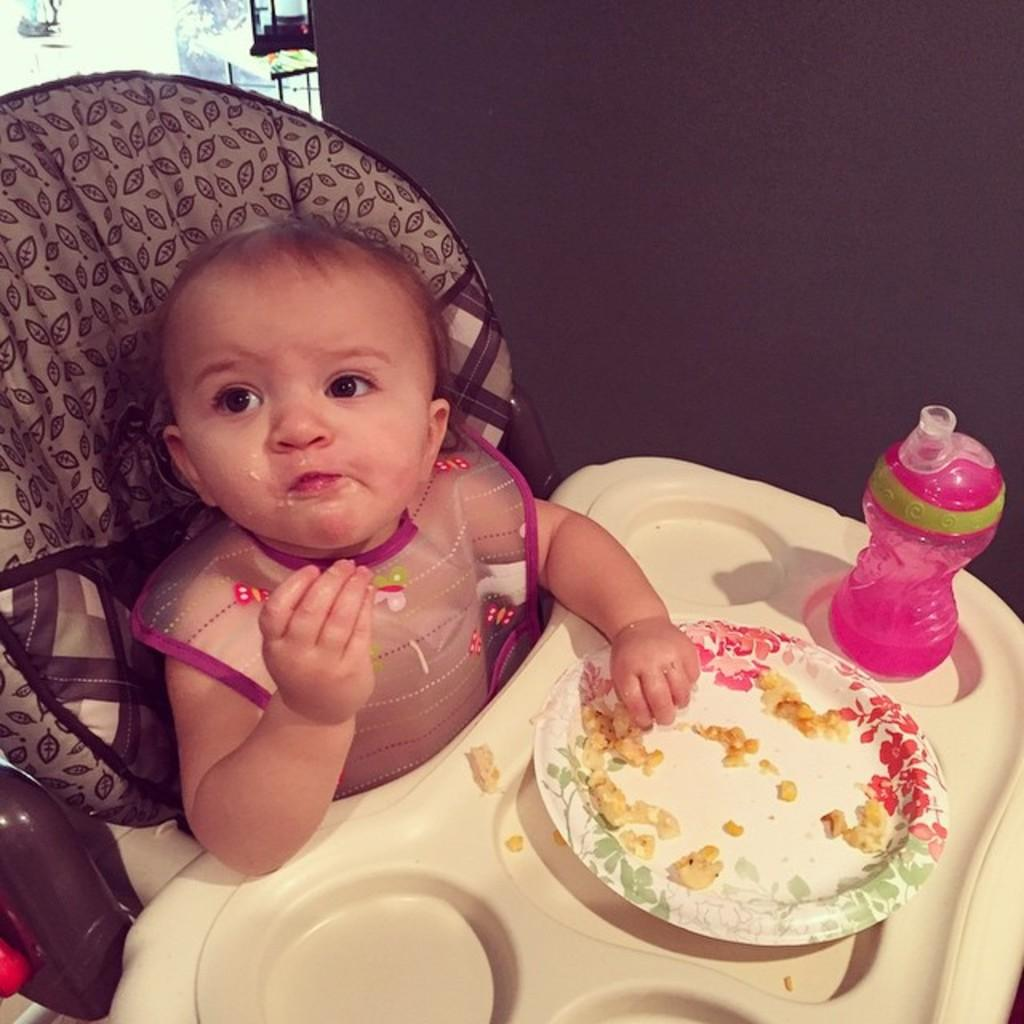What is the main subject in the image? There is a kid in the stroller. What is the kid doing in the image? The kid is eating food. What can be seen beside the food in the image? There is a water bottle beside the food. What type of feet can be seen on the coach in the image? There is no coach or feet present in the image; it features a kid in a stroller eating food and a water bottle beside the food. 